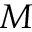<formula> <loc_0><loc_0><loc_500><loc_500>M</formula> 